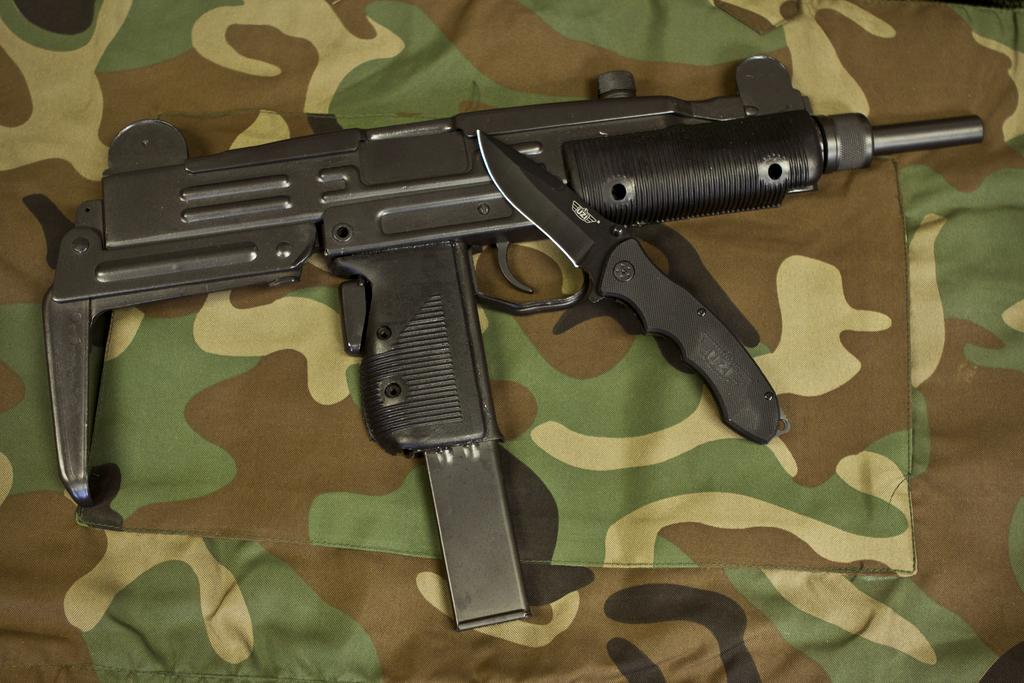What type of cloth is present in the image? There is a camouflage cloth in the image. What objects are placed on the cloth? There is a black color gun and a black color knife on the cloth. Are there any cobwebs visible on the gun or knife in the image? There is no mention of cobwebs in the image, so we cannot determine if they are present on the gun or knife. 